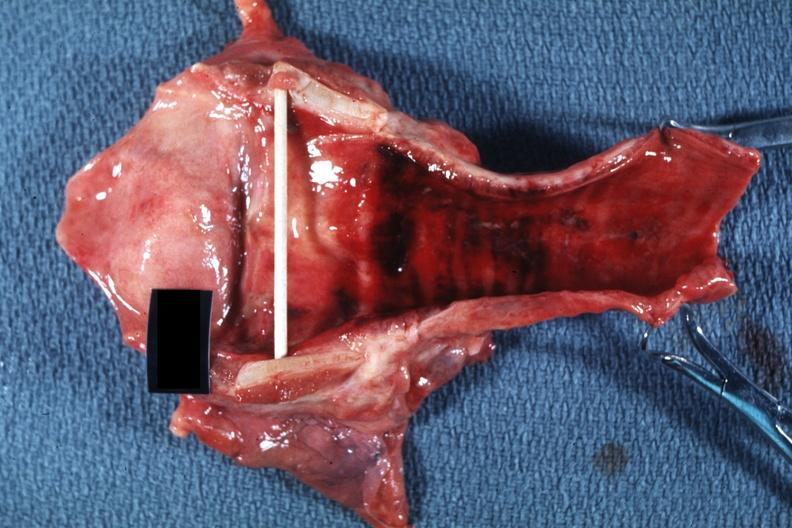does heart show good example probably due to intubation?
Answer the question using a single word or phrase. No 